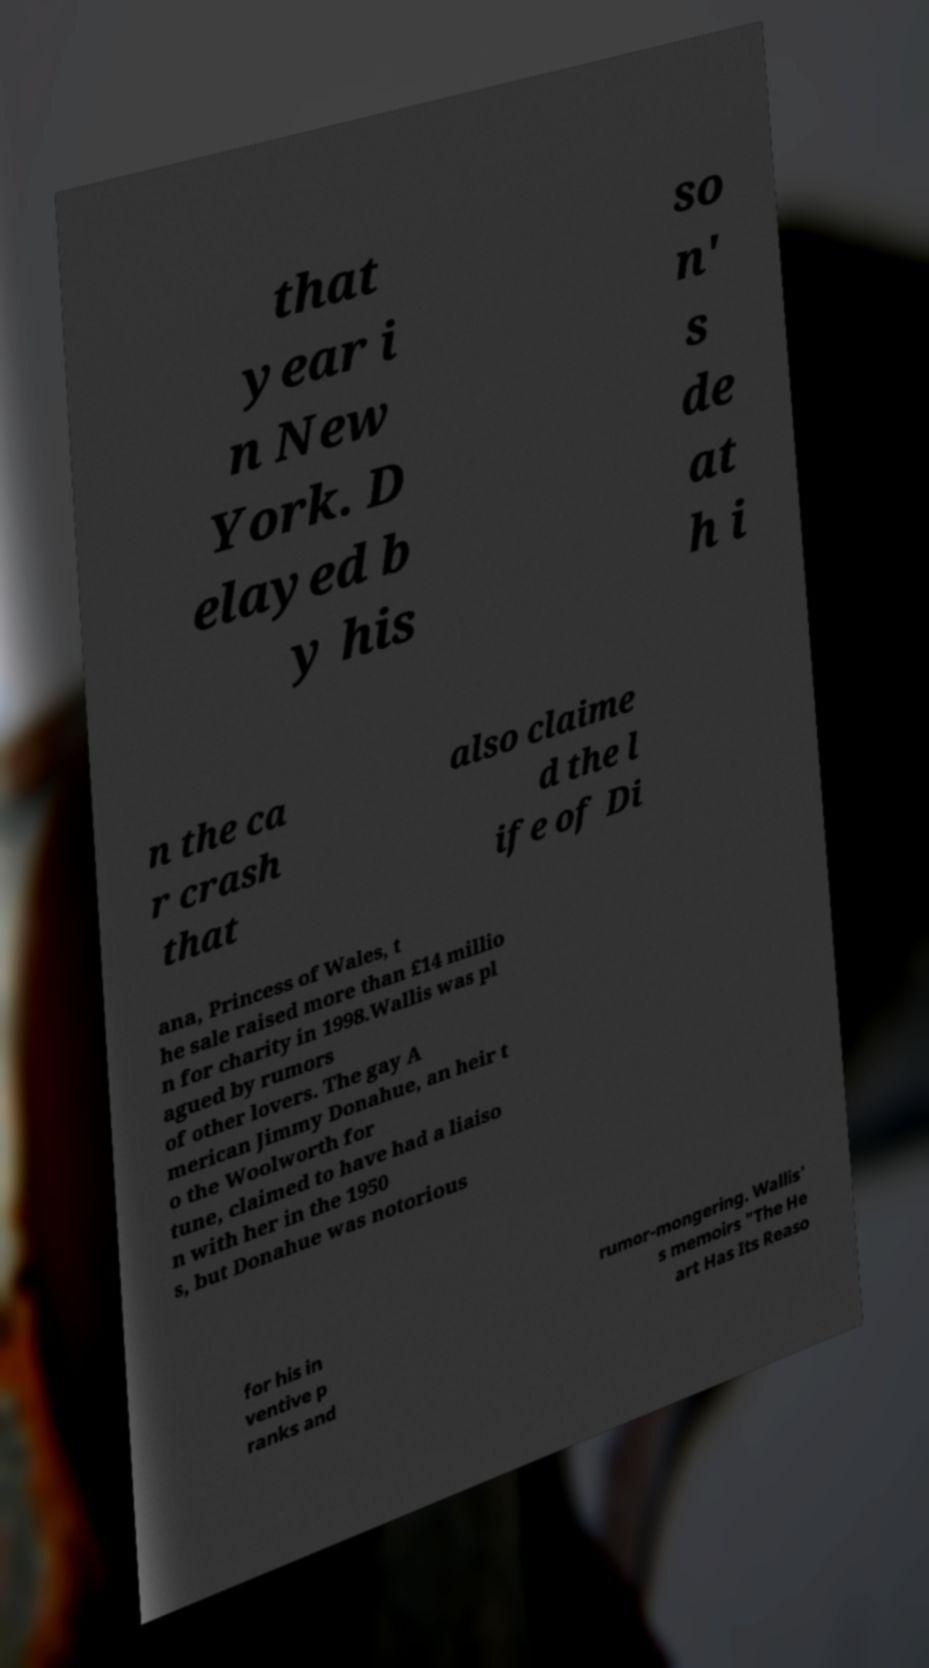Please read and relay the text visible in this image. What does it say? that year i n New York. D elayed b y his so n' s de at h i n the ca r crash that also claime d the l ife of Di ana, Princess of Wales, t he sale raised more than £14 millio n for charity in 1998.Wallis was pl agued by rumors of other lovers. The gay A merican Jimmy Donahue, an heir t o the Woolworth for tune, claimed to have had a liaiso n with her in the 1950 s, but Donahue was notorious for his in ventive p ranks and rumor-mongering. Wallis' s memoirs "The He art Has Its Reaso 